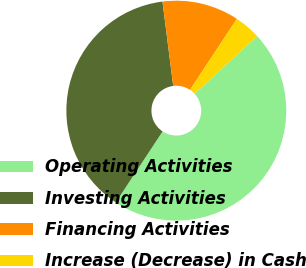Convert chart to OTSL. <chart><loc_0><loc_0><loc_500><loc_500><pie_chart><fcel>Operating Activities<fcel>Investing Activities<fcel>Financing Activities<fcel>Increase (Decrease) in Cash<nl><fcel>46.14%<fcel>38.71%<fcel>11.29%<fcel>3.86%<nl></chart> 